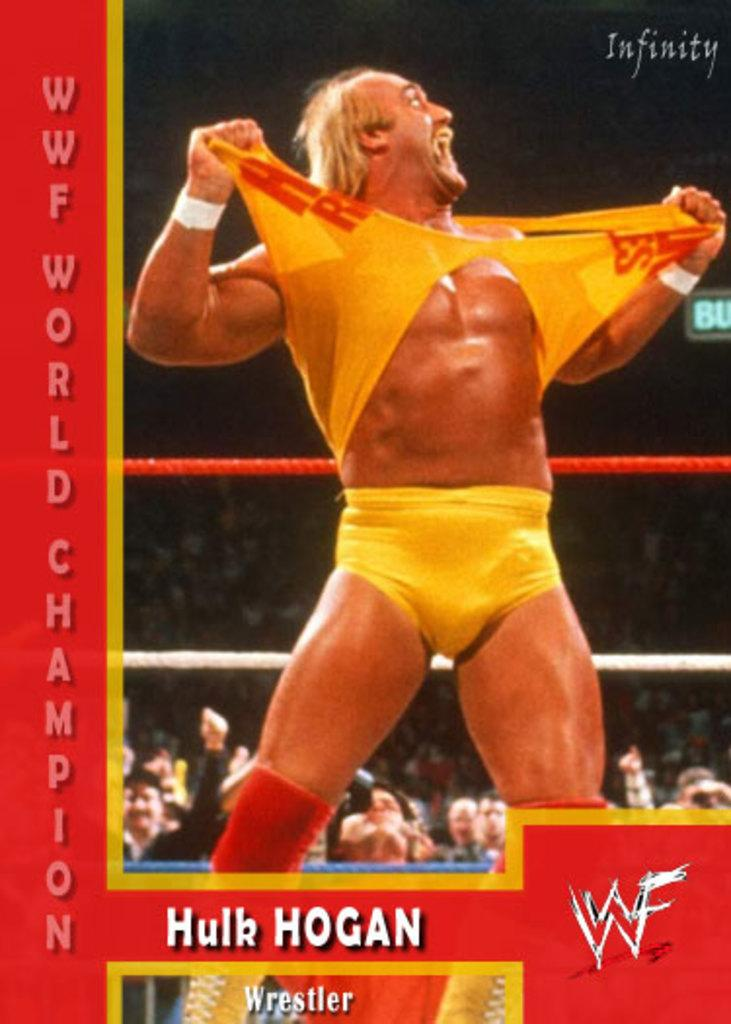<image>
Describe the image concisely. Hulk Hogan, the WWF world champion tears apart a shirt. 